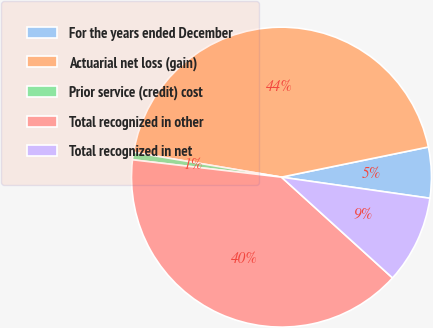Convert chart. <chart><loc_0><loc_0><loc_500><loc_500><pie_chart><fcel>For the years ended December<fcel>Actuarial net loss (gain)<fcel>Prior service (credit) cost<fcel>Total recognized in other<fcel>Total recognized in net<nl><fcel>5.47%<fcel>44.13%<fcel>0.8%<fcel>40.12%<fcel>9.48%<nl></chart> 